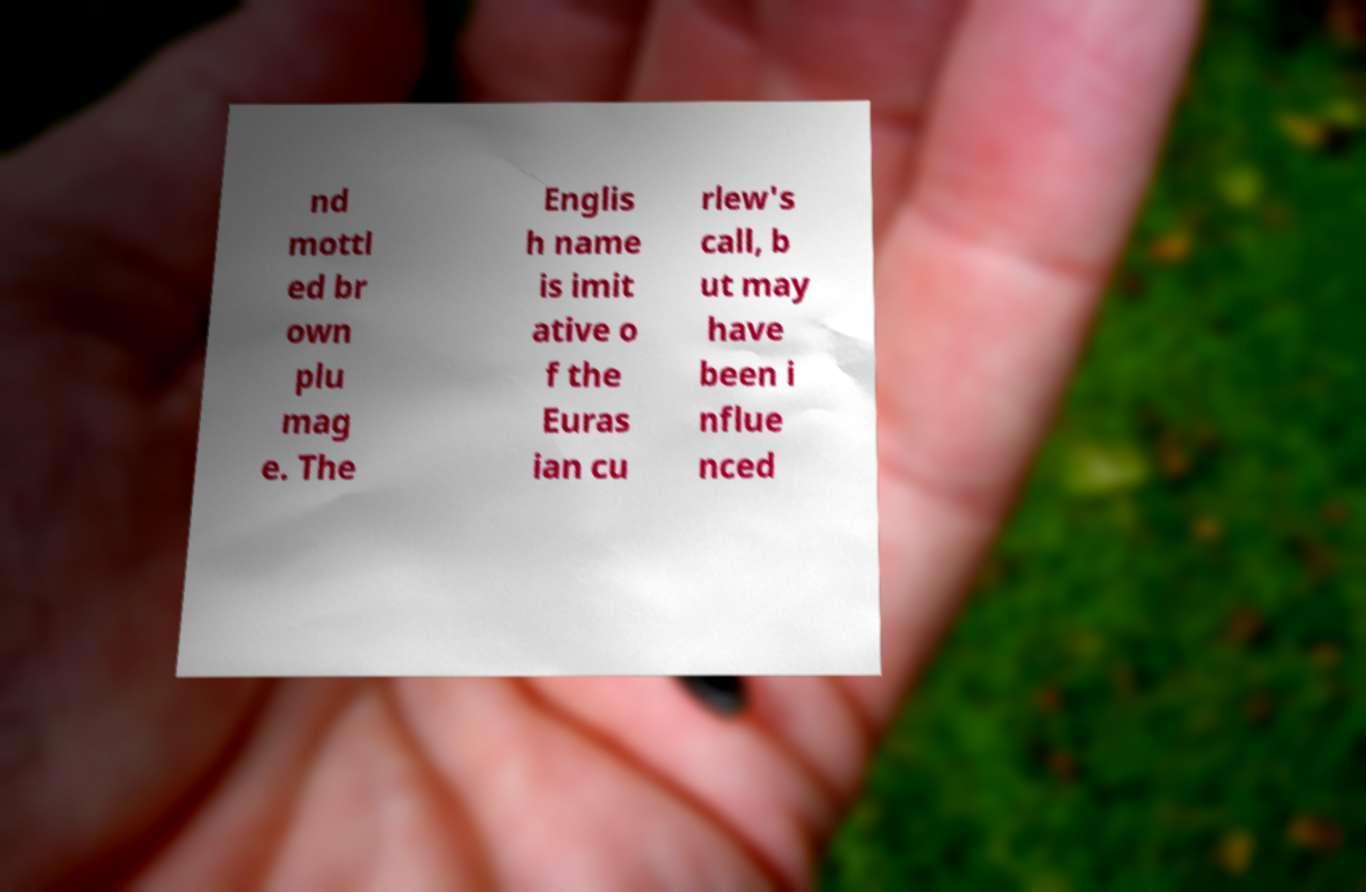I need the written content from this picture converted into text. Can you do that? nd mottl ed br own plu mag e. The Englis h name is imit ative o f the Euras ian cu rlew's call, b ut may have been i nflue nced 